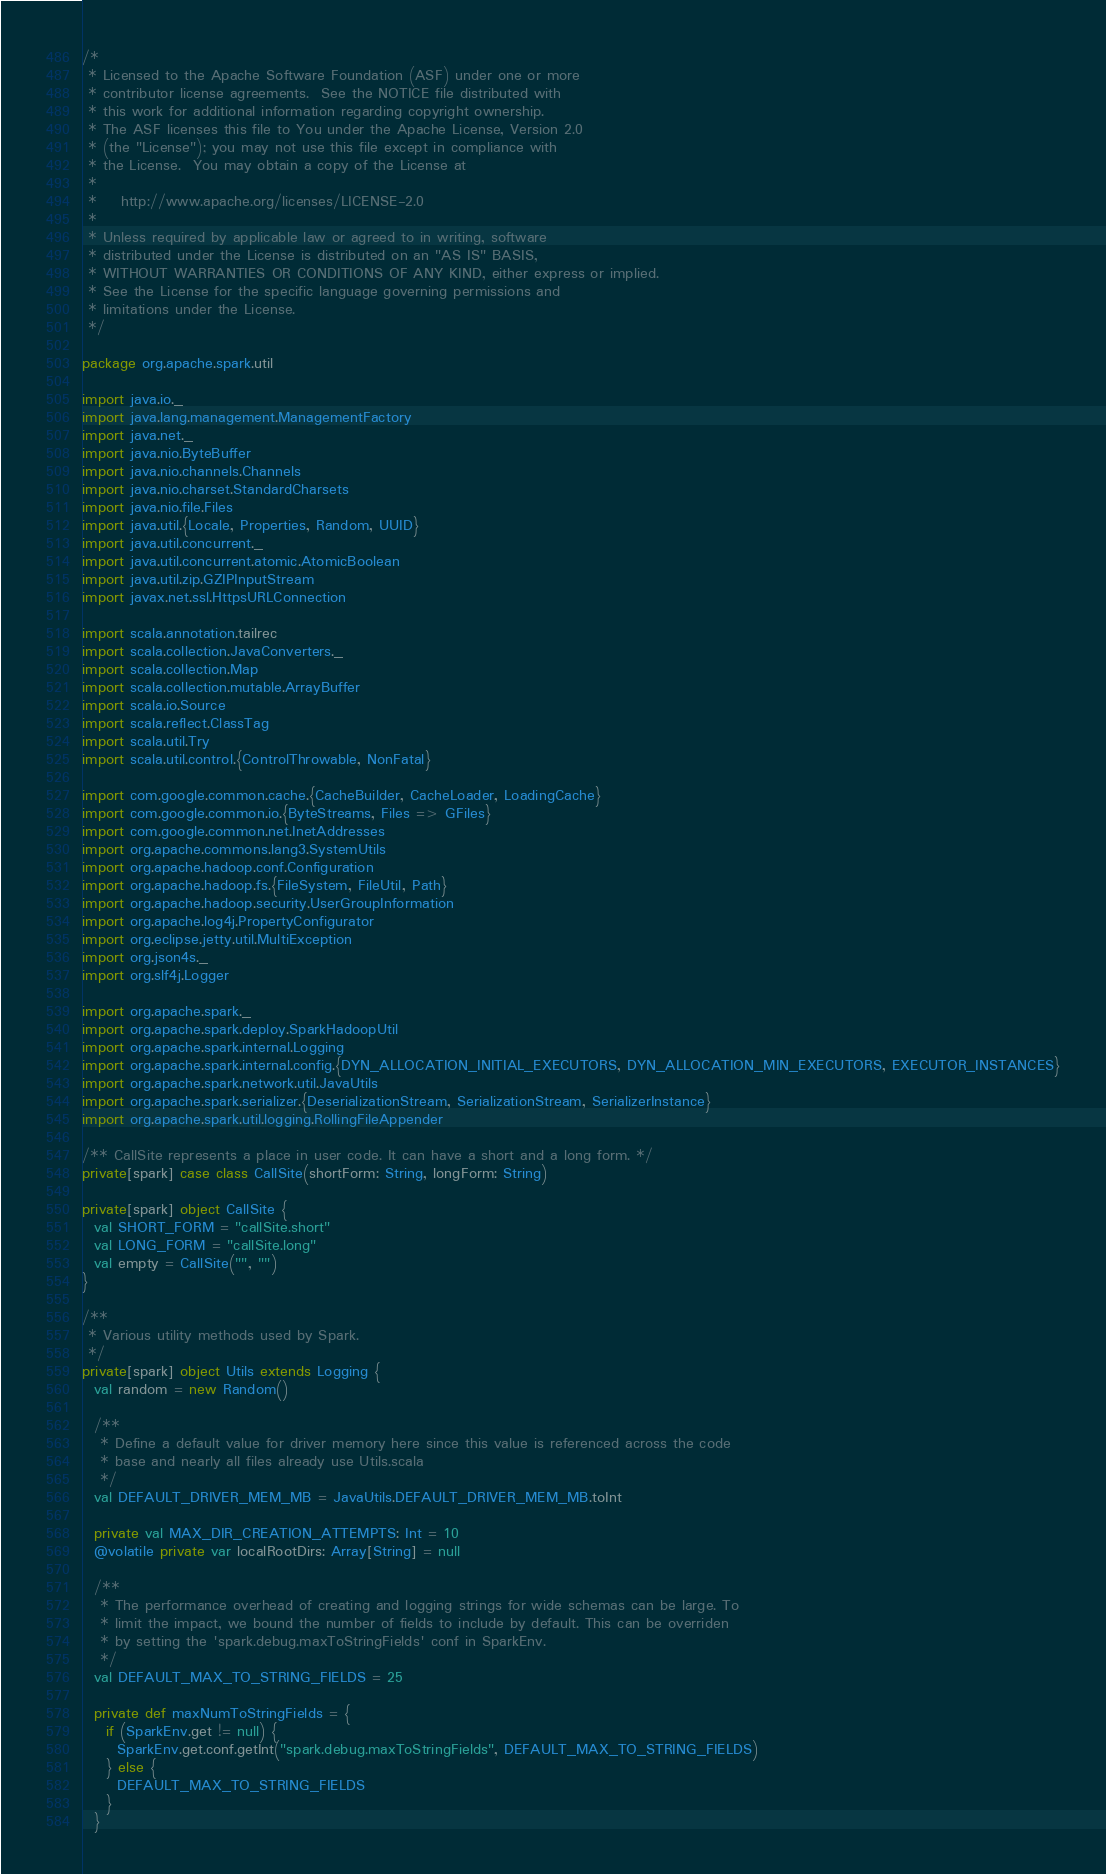<code> <loc_0><loc_0><loc_500><loc_500><_Scala_>/*
 * Licensed to the Apache Software Foundation (ASF) under one or more
 * contributor license agreements.  See the NOTICE file distributed with
 * this work for additional information regarding copyright ownership.
 * The ASF licenses this file to You under the Apache License, Version 2.0
 * (the "License"); you may not use this file except in compliance with
 * the License.  You may obtain a copy of the License at
 *
 *    http://www.apache.org/licenses/LICENSE-2.0
 *
 * Unless required by applicable law or agreed to in writing, software
 * distributed under the License is distributed on an "AS IS" BASIS,
 * WITHOUT WARRANTIES OR CONDITIONS OF ANY KIND, either express or implied.
 * See the License for the specific language governing permissions and
 * limitations under the License.
 */

package org.apache.spark.util

import java.io._
import java.lang.management.ManagementFactory
import java.net._
import java.nio.ByteBuffer
import java.nio.channels.Channels
import java.nio.charset.StandardCharsets
import java.nio.file.Files
import java.util.{Locale, Properties, Random, UUID}
import java.util.concurrent._
import java.util.concurrent.atomic.AtomicBoolean
import java.util.zip.GZIPInputStream
import javax.net.ssl.HttpsURLConnection

import scala.annotation.tailrec
import scala.collection.JavaConverters._
import scala.collection.Map
import scala.collection.mutable.ArrayBuffer
import scala.io.Source
import scala.reflect.ClassTag
import scala.util.Try
import scala.util.control.{ControlThrowable, NonFatal}

import com.google.common.cache.{CacheBuilder, CacheLoader, LoadingCache}
import com.google.common.io.{ByteStreams, Files => GFiles}
import com.google.common.net.InetAddresses
import org.apache.commons.lang3.SystemUtils
import org.apache.hadoop.conf.Configuration
import org.apache.hadoop.fs.{FileSystem, FileUtil, Path}
import org.apache.hadoop.security.UserGroupInformation
import org.apache.log4j.PropertyConfigurator
import org.eclipse.jetty.util.MultiException
import org.json4s._
import org.slf4j.Logger

import org.apache.spark._
import org.apache.spark.deploy.SparkHadoopUtil
import org.apache.spark.internal.Logging
import org.apache.spark.internal.config.{DYN_ALLOCATION_INITIAL_EXECUTORS, DYN_ALLOCATION_MIN_EXECUTORS, EXECUTOR_INSTANCES}
import org.apache.spark.network.util.JavaUtils
import org.apache.spark.serializer.{DeserializationStream, SerializationStream, SerializerInstance}
import org.apache.spark.util.logging.RollingFileAppender

/** CallSite represents a place in user code. It can have a short and a long form. */
private[spark] case class CallSite(shortForm: String, longForm: String)

private[spark] object CallSite {
  val SHORT_FORM = "callSite.short"
  val LONG_FORM = "callSite.long"
  val empty = CallSite("", "")
}

/**
 * Various utility methods used by Spark.
 */
private[spark] object Utils extends Logging {
  val random = new Random()

  /**
   * Define a default value for driver memory here since this value is referenced across the code
   * base and nearly all files already use Utils.scala
   */
  val DEFAULT_DRIVER_MEM_MB = JavaUtils.DEFAULT_DRIVER_MEM_MB.toInt

  private val MAX_DIR_CREATION_ATTEMPTS: Int = 10
  @volatile private var localRootDirs: Array[String] = null

  /**
   * The performance overhead of creating and logging strings for wide schemas can be large. To
   * limit the impact, we bound the number of fields to include by default. This can be overriden
   * by setting the 'spark.debug.maxToStringFields' conf in SparkEnv.
   */
  val DEFAULT_MAX_TO_STRING_FIELDS = 25

  private def maxNumToStringFields = {
    if (SparkEnv.get != null) {
      SparkEnv.get.conf.getInt("spark.debug.maxToStringFields", DEFAULT_MAX_TO_STRING_FIELDS)
    } else {
      DEFAULT_MAX_TO_STRING_FIELDS
    }
  }
</code> 